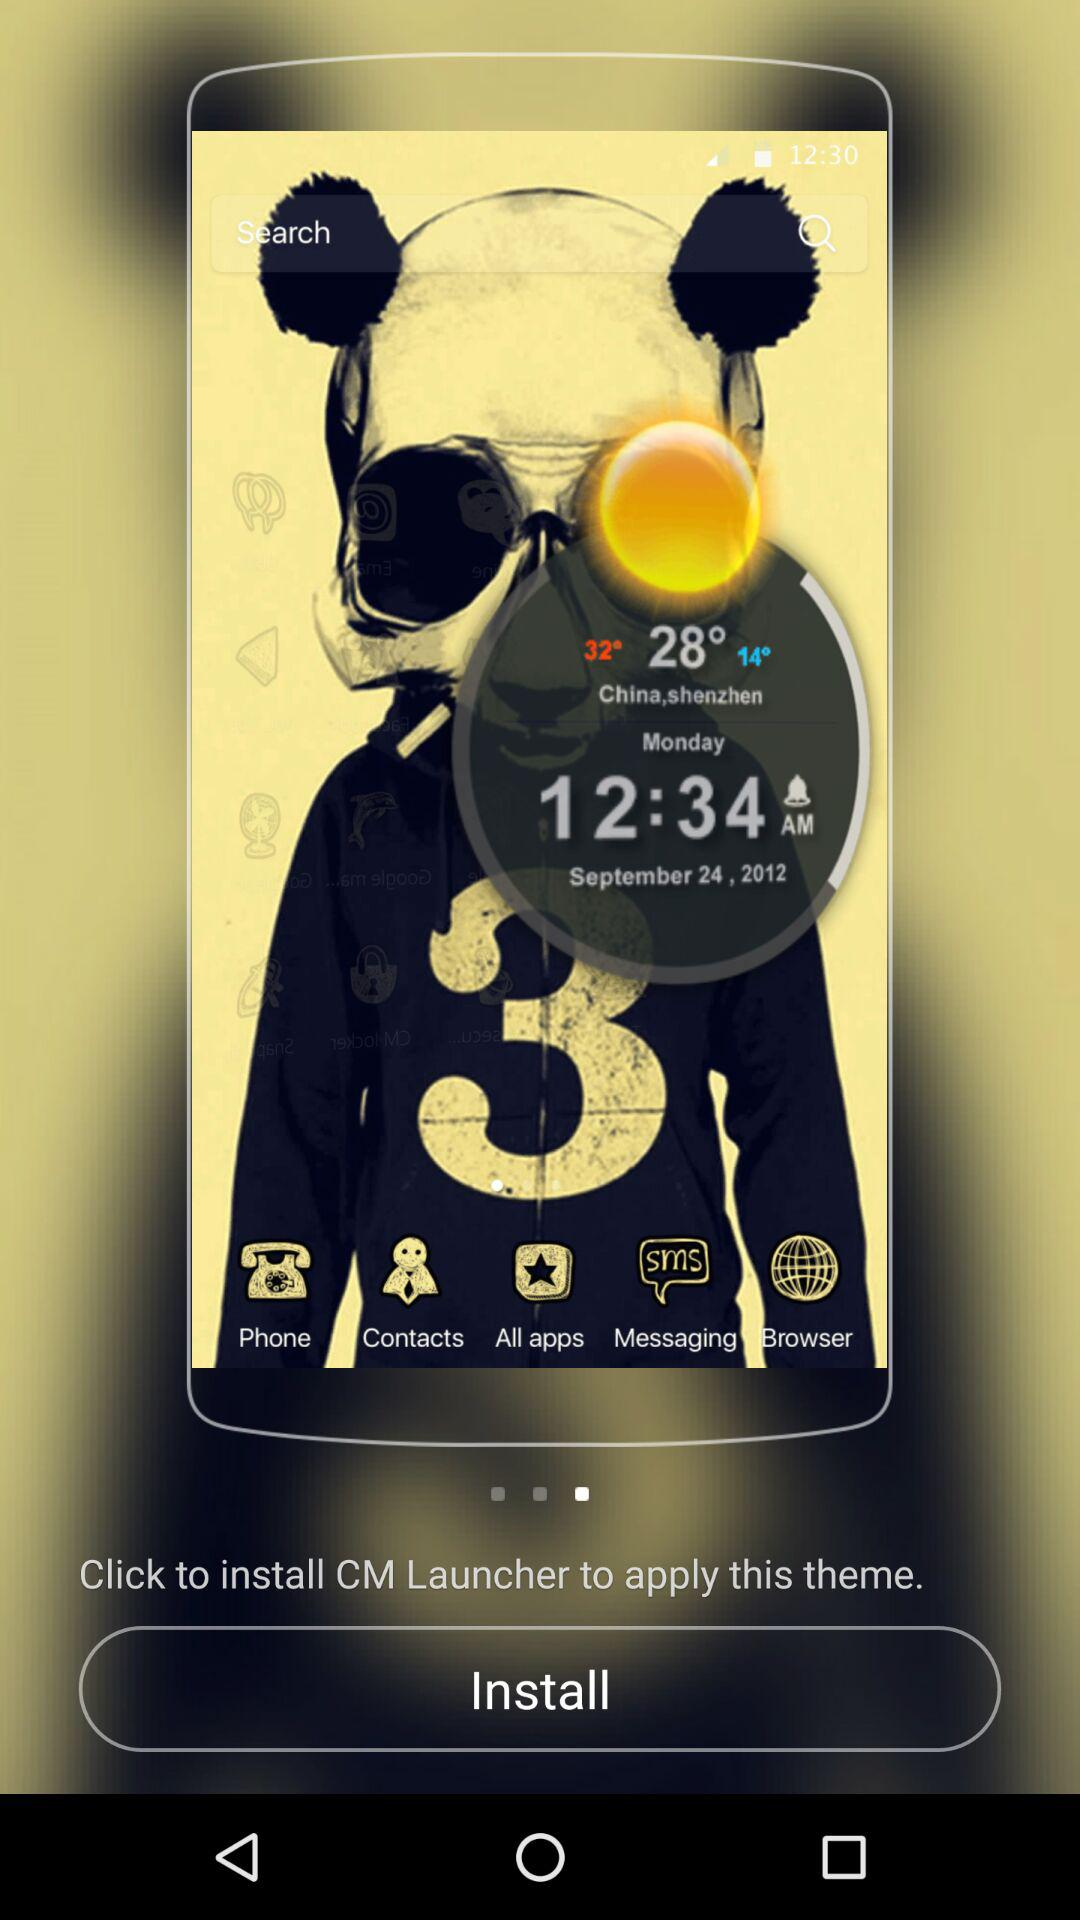What was the day on 24th September? The day was Monday. 